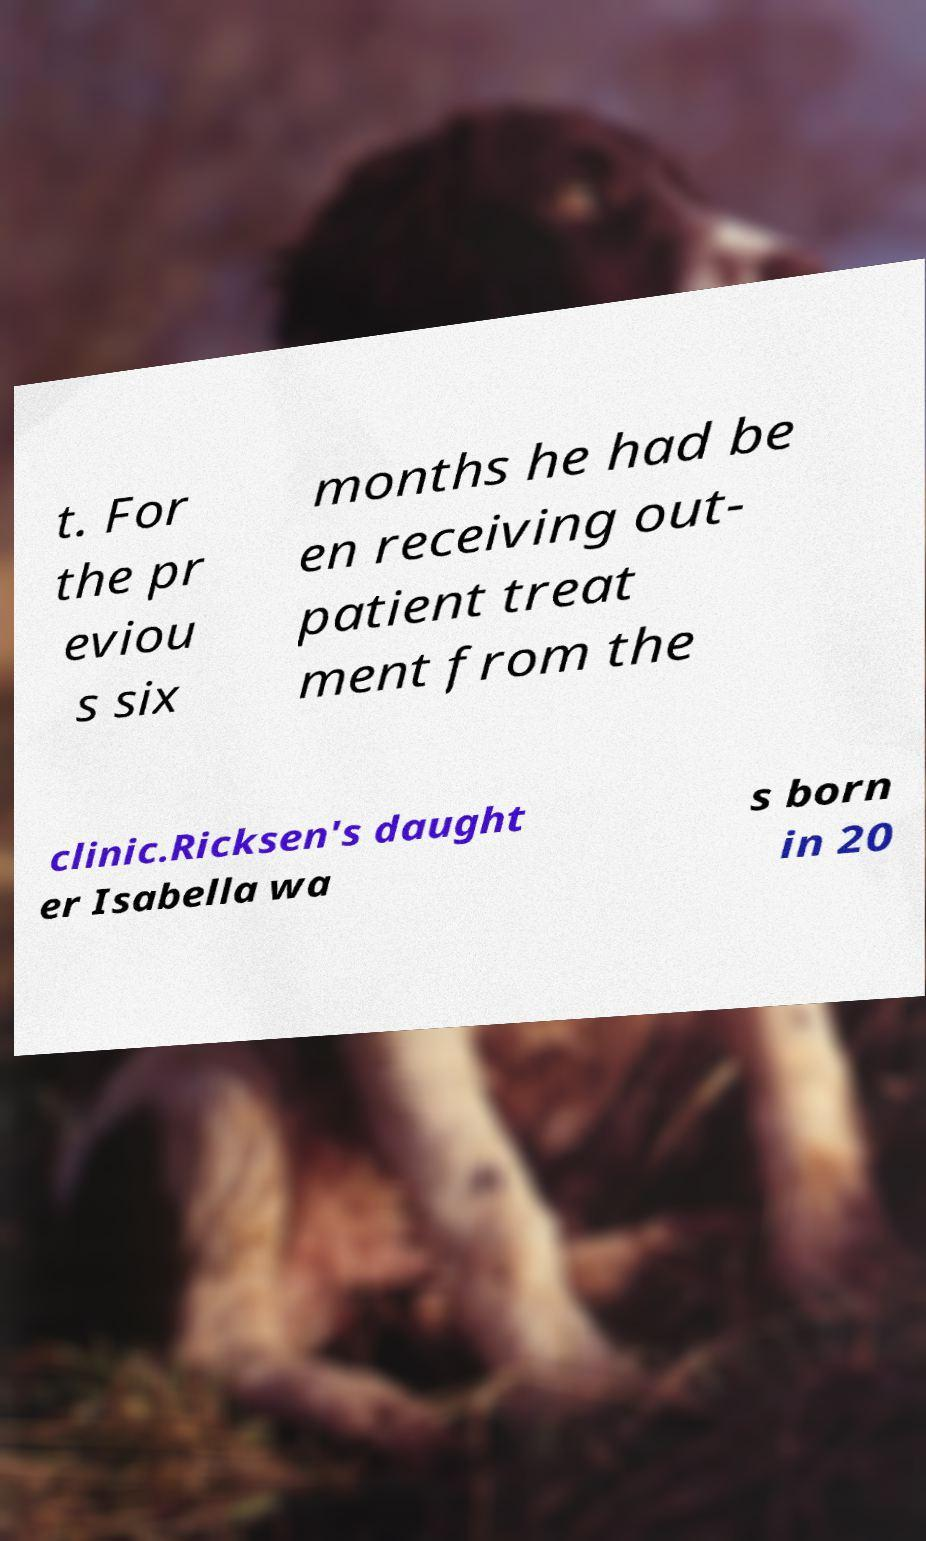Could you assist in decoding the text presented in this image and type it out clearly? t. For the pr eviou s six months he had be en receiving out- patient treat ment from the clinic.Ricksen's daught er Isabella wa s born in 20 